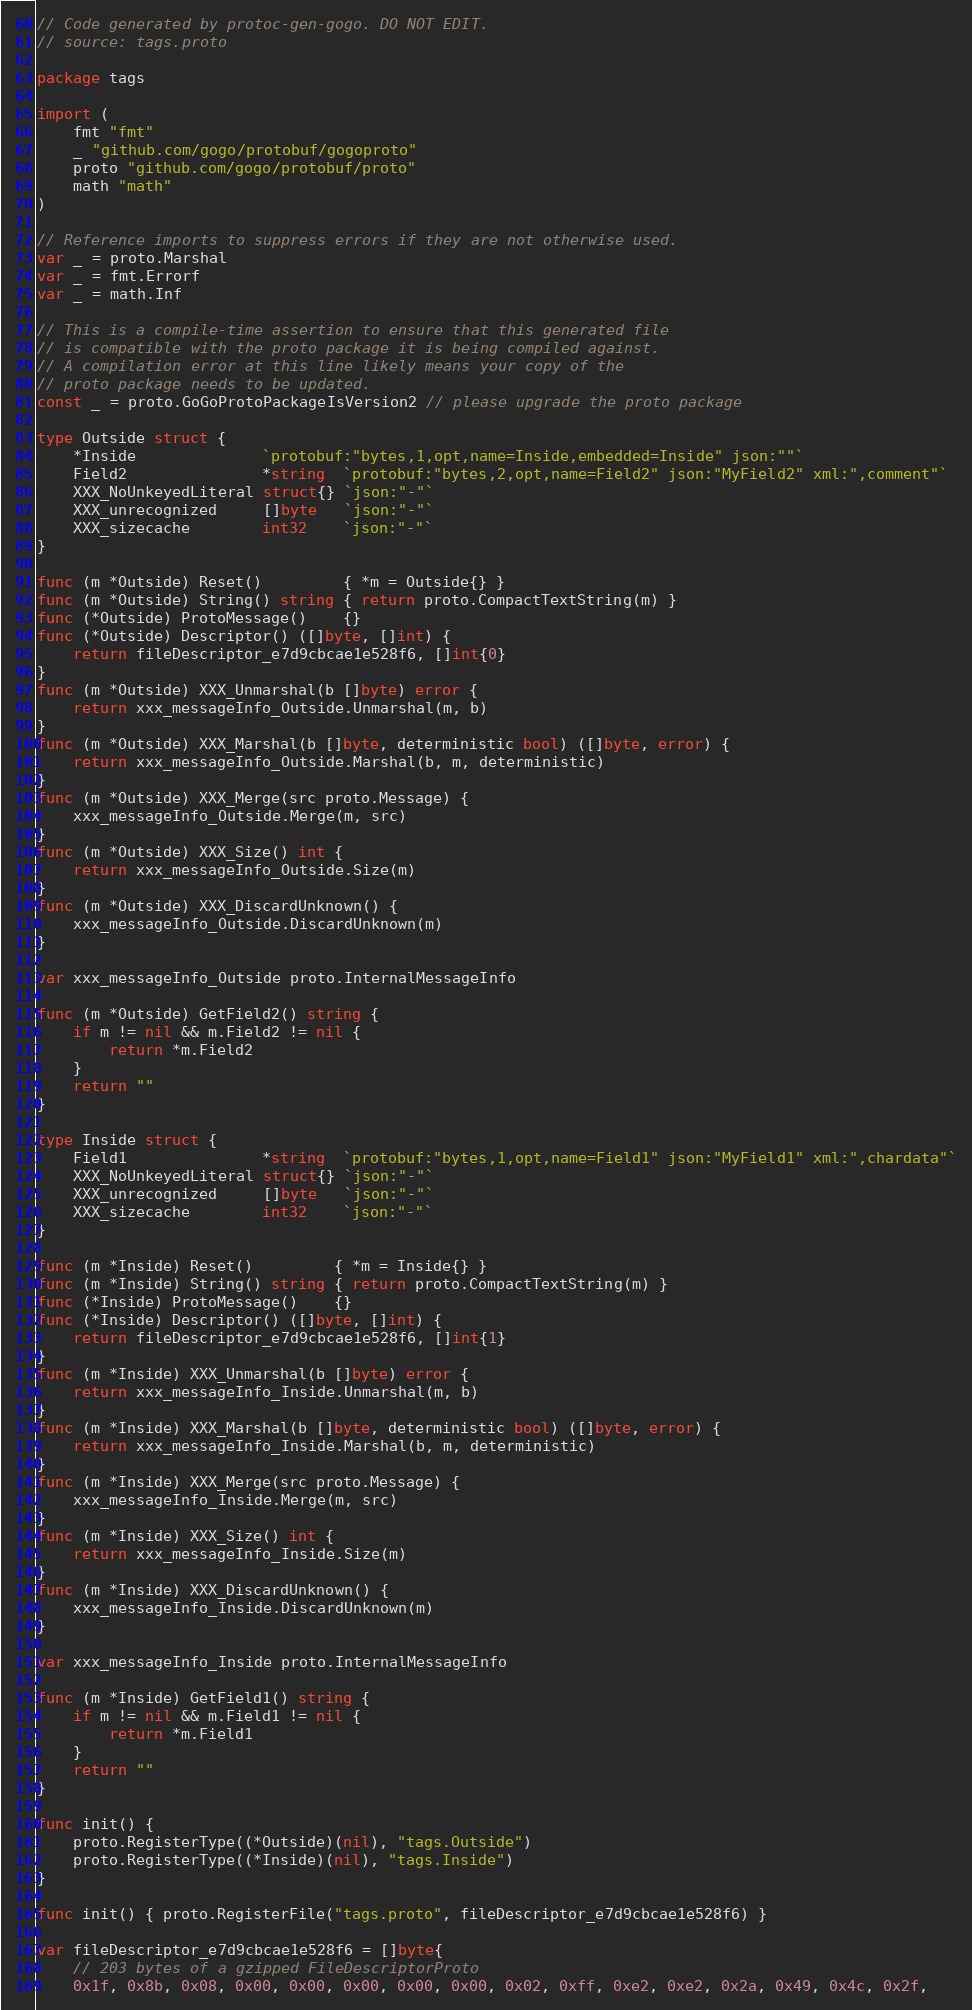Convert code to text. <code><loc_0><loc_0><loc_500><loc_500><_Go_>// Code generated by protoc-gen-gogo. DO NOT EDIT.
// source: tags.proto

package tags

import (
	fmt "fmt"
	_ "github.com/gogo/protobuf/gogoproto"
	proto "github.com/gogo/protobuf/proto"
	math "math"
)

// Reference imports to suppress errors if they are not otherwise used.
var _ = proto.Marshal
var _ = fmt.Errorf
var _ = math.Inf

// This is a compile-time assertion to ensure that this generated file
// is compatible with the proto package it is being compiled against.
// A compilation error at this line likely means your copy of the
// proto package needs to be updated.
const _ = proto.GoGoProtoPackageIsVersion2 // please upgrade the proto package

type Outside struct {
	*Inside              `protobuf:"bytes,1,opt,name=Inside,embedded=Inside" json:""`
	Field2               *string  `protobuf:"bytes,2,opt,name=Field2" json:"MyField2" xml:",comment"`
	XXX_NoUnkeyedLiteral struct{} `json:"-"`
	XXX_unrecognized     []byte   `json:"-"`
	XXX_sizecache        int32    `json:"-"`
}

func (m *Outside) Reset()         { *m = Outside{} }
func (m *Outside) String() string { return proto.CompactTextString(m) }
func (*Outside) ProtoMessage()    {}
func (*Outside) Descriptor() ([]byte, []int) {
	return fileDescriptor_e7d9cbcae1e528f6, []int{0}
}
func (m *Outside) XXX_Unmarshal(b []byte) error {
	return xxx_messageInfo_Outside.Unmarshal(m, b)
}
func (m *Outside) XXX_Marshal(b []byte, deterministic bool) ([]byte, error) {
	return xxx_messageInfo_Outside.Marshal(b, m, deterministic)
}
func (m *Outside) XXX_Merge(src proto.Message) {
	xxx_messageInfo_Outside.Merge(m, src)
}
func (m *Outside) XXX_Size() int {
	return xxx_messageInfo_Outside.Size(m)
}
func (m *Outside) XXX_DiscardUnknown() {
	xxx_messageInfo_Outside.DiscardUnknown(m)
}

var xxx_messageInfo_Outside proto.InternalMessageInfo

func (m *Outside) GetField2() string {
	if m != nil && m.Field2 != nil {
		return *m.Field2
	}
	return ""
}

type Inside struct {
	Field1               *string  `protobuf:"bytes,1,opt,name=Field1" json:"MyField1" xml:",chardata"`
	XXX_NoUnkeyedLiteral struct{} `json:"-"`
	XXX_unrecognized     []byte   `json:"-"`
	XXX_sizecache        int32    `json:"-"`
}

func (m *Inside) Reset()         { *m = Inside{} }
func (m *Inside) String() string { return proto.CompactTextString(m) }
func (*Inside) ProtoMessage()    {}
func (*Inside) Descriptor() ([]byte, []int) {
	return fileDescriptor_e7d9cbcae1e528f6, []int{1}
}
func (m *Inside) XXX_Unmarshal(b []byte) error {
	return xxx_messageInfo_Inside.Unmarshal(m, b)
}
func (m *Inside) XXX_Marshal(b []byte, deterministic bool) ([]byte, error) {
	return xxx_messageInfo_Inside.Marshal(b, m, deterministic)
}
func (m *Inside) XXX_Merge(src proto.Message) {
	xxx_messageInfo_Inside.Merge(m, src)
}
func (m *Inside) XXX_Size() int {
	return xxx_messageInfo_Inside.Size(m)
}
func (m *Inside) XXX_DiscardUnknown() {
	xxx_messageInfo_Inside.DiscardUnknown(m)
}

var xxx_messageInfo_Inside proto.InternalMessageInfo

func (m *Inside) GetField1() string {
	if m != nil && m.Field1 != nil {
		return *m.Field1
	}
	return ""
}

func init() {
	proto.RegisterType((*Outside)(nil), "tags.Outside")
	proto.RegisterType((*Inside)(nil), "tags.Inside")
}

func init() { proto.RegisterFile("tags.proto", fileDescriptor_e7d9cbcae1e528f6) }

var fileDescriptor_e7d9cbcae1e528f6 = []byte{
	// 203 bytes of a gzipped FileDescriptorProto
	0x1f, 0x8b, 0x08, 0x00, 0x00, 0x00, 0x00, 0x00, 0x02, 0xff, 0xe2, 0xe2, 0x2a, 0x49, 0x4c, 0x2f,</code> 